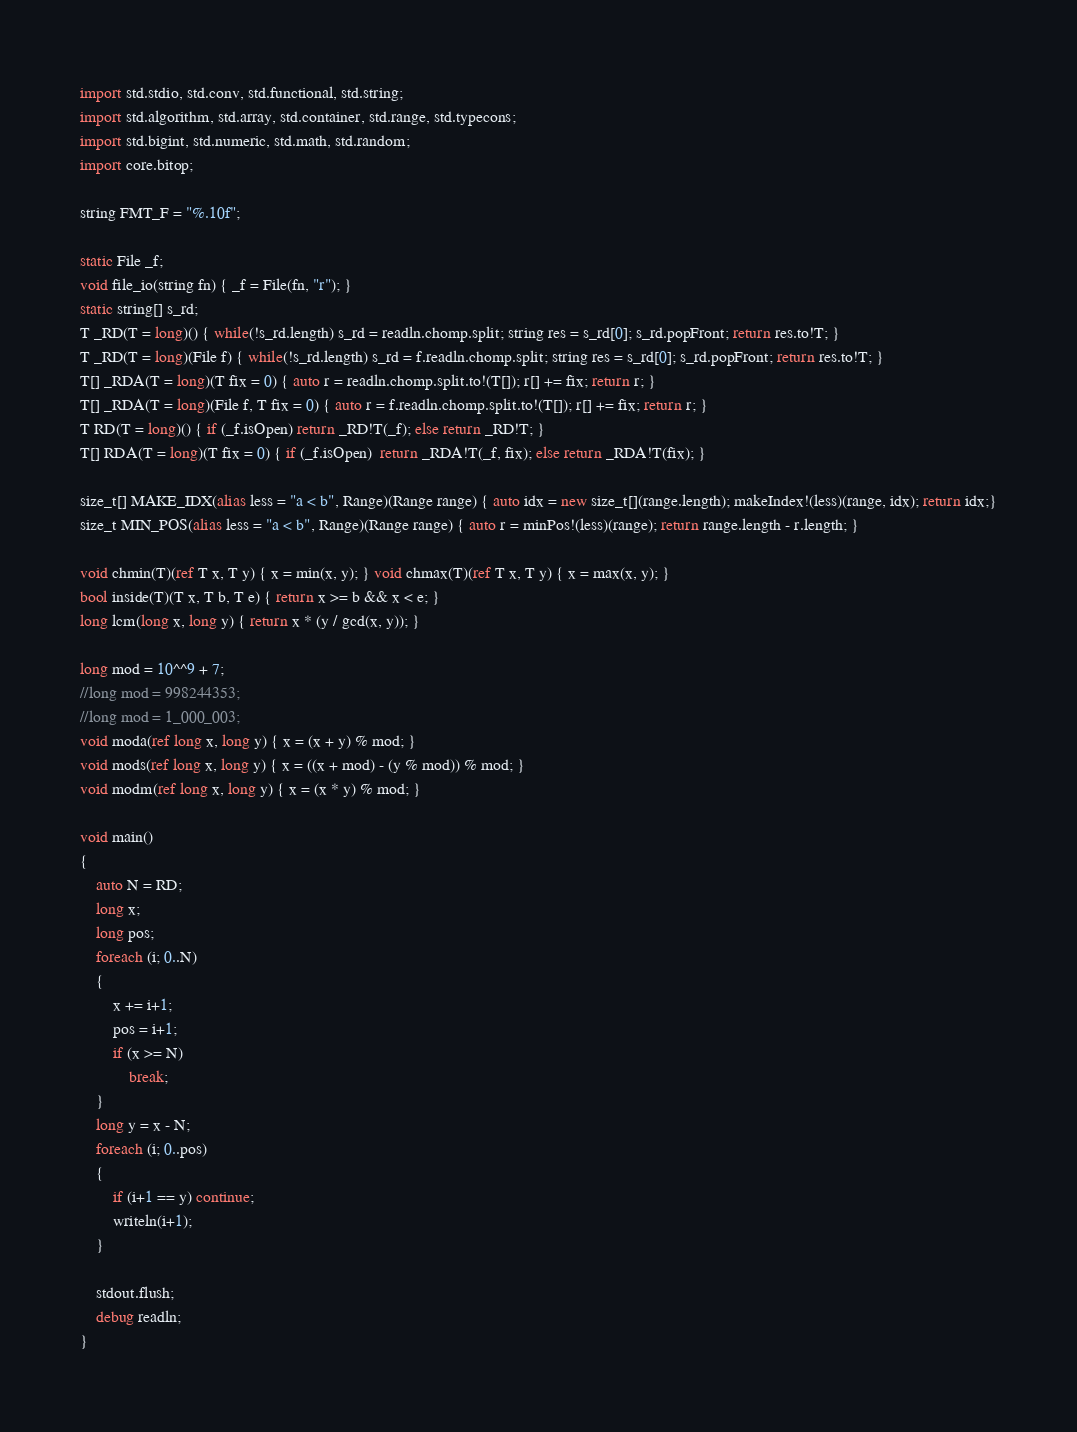<code> <loc_0><loc_0><loc_500><loc_500><_D_>import std.stdio, std.conv, std.functional, std.string;
import std.algorithm, std.array, std.container, std.range, std.typecons;
import std.bigint, std.numeric, std.math, std.random;
import core.bitop;

string FMT_F = "%.10f";

static File _f;
void file_io(string fn) { _f = File(fn, "r"); }
static string[] s_rd;
T _RD(T = long)() { while(!s_rd.length) s_rd = readln.chomp.split; string res = s_rd[0]; s_rd.popFront; return res.to!T; }
T _RD(T = long)(File f) { while(!s_rd.length) s_rd = f.readln.chomp.split; string res = s_rd[0]; s_rd.popFront; return res.to!T; }
T[] _RDA(T = long)(T fix = 0) { auto r = readln.chomp.split.to!(T[]); r[] += fix; return r; }
T[] _RDA(T = long)(File f, T fix = 0) { auto r = f.readln.chomp.split.to!(T[]); r[] += fix; return r; }
T RD(T = long)() { if (_f.isOpen) return _RD!T(_f); else return _RD!T; }
T[] RDA(T = long)(T fix = 0) { if (_f.isOpen)  return _RDA!T(_f, fix); else return _RDA!T(fix); }

size_t[] MAKE_IDX(alias less = "a < b", Range)(Range range) { auto idx = new size_t[](range.length); makeIndex!(less)(range, idx); return idx;}
size_t MIN_POS(alias less = "a < b", Range)(Range range) { auto r = minPos!(less)(range); return range.length - r.length; }

void chmin(T)(ref T x, T y) { x = min(x, y); } void chmax(T)(ref T x, T y) { x = max(x, y); }
bool inside(T)(T x, T b, T e) { return x >= b && x < e; }
long lcm(long x, long y) { return x * (y / gcd(x, y)); }

long mod = 10^^9 + 7;
//long mod = 998244353;
//long mod = 1_000_003;
void moda(ref long x, long y) { x = (x + y) % mod; }
void mods(ref long x, long y) { x = ((x + mod) - (y % mod)) % mod; }
void modm(ref long x, long y) { x = (x * y) % mod; }

void main()
{
	auto N = RD;
	long x;
	long pos;
	foreach (i; 0..N)
	{
		x += i+1;
		pos = i+1;
		if (x >= N)
			break;
	}
	long y = x - N;
	foreach (i; 0..pos)
	{
		if (i+1 == y) continue;
		writeln(i+1);
	}

	stdout.flush;
	debug readln;
}</code> 